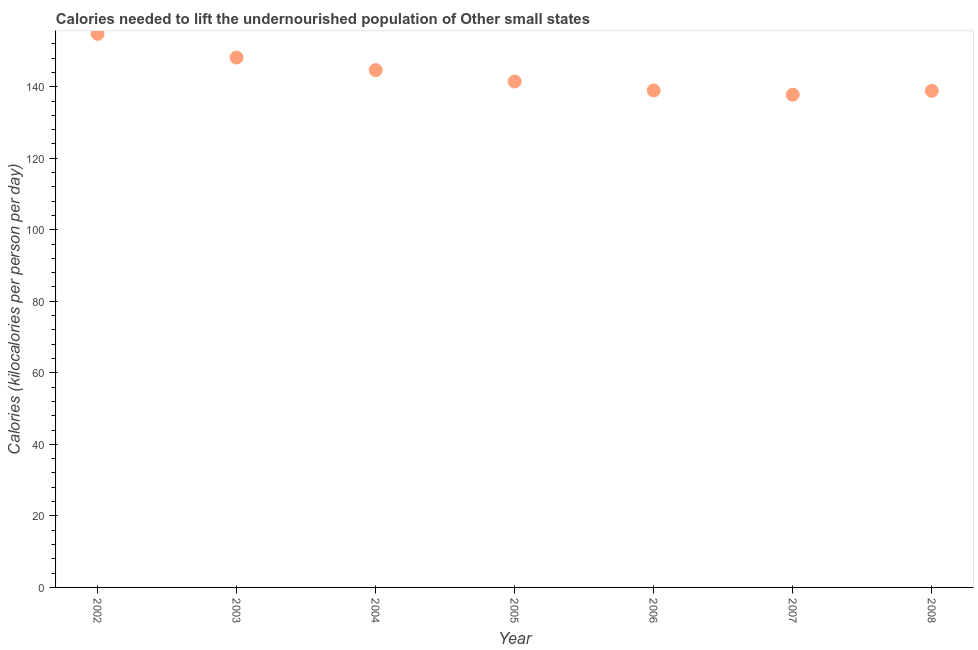What is the depth of food deficit in 2002?
Offer a terse response. 154.77. Across all years, what is the maximum depth of food deficit?
Your response must be concise. 154.77. Across all years, what is the minimum depth of food deficit?
Offer a very short reply. 137.76. What is the sum of the depth of food deficit?
Provide a succinct answer. 1004.58. What is the difference between the depth of food deficit in 2002 and 2008?
Your answer should be compact. 15.92. What is the average depth of food deficit per year?
Ensure brevity in your answer.  143.51. What is the median depth of food deficit?
Provide a short and direct response. 141.45. In how many years, is the depth of food deficit greater than 100 kilocalories?
Keep it short and to the point. 7. Do a majority of the years between 2006 and 2003 (inclusive) have depth of food deficit greater than 112 kilocalories?
Ensure brevity in your answer.  Yes. What is the ratio of the depth of food deficit in 2003 to that in 2004?
Make the answer very short. 1.02. What is the difference between the highest and the second highest depth of food deficit?
Give a very brief answer. 6.62. Is the sum of the depth of food deficit in 2006 and 2007 greater than the maximum depth of food deficit across all years?
Give a very brief answer. Yes. What is the difference between the highest and the lowest depth of food deficit?
Give a very brief answer. 17.01. In how many years, is the depth of food deficit greater than the average depth of food deficit taken over all years?
Offer a very short reply. 3. How many years are there in the graph?
Provide a succinct answer. 7. Are the values on the major ticks of Y-axis written in scientific E-notation?
Offer a terse response. No. Does the graph contain grids?
Provide a short and direct response. No. What is the title of the graph?
Make the answer very short. Calories needed to lift the undernourished population of Other small states. What is the label or title of the X-axis?
Make the answer very short. Year. What is the label or title of the Y-axis?
Your answer should be very brief. Calories (kilocalories per person per day). What is the Calories (kilocalories per person per day) in 2002?
Make the answer very short. 154.77. What is the Calories (kilocalories per person per day) in 2003?
Offer a very short reply. 148.15. What is the Calories (kilocalories per person per day) in 2004?
Your response must be concise. 144.65. What is the Calories (kilocalories per person per day) in 2005?
Make the answer very short. 141.45. What is the Calories (kilocalories per person per day) in 2006?
Your answer should be compact. 138.96. What is the Calories (kilocalories per person per day) in 2007?
Provide a succinct answer. 137.76. What is the Calories (kilocalories per person per day) in 2008?
Your response must be concise. 138.85. What is the difference between the Calories (kilocalories per person per day) in 2002 and 2003?
Offer a very short reply. 6.62. What is the difference between the Calories (kilocalories per person per day) in 2002 and 2004?
Keep it short and to the point. 10.13. What is the difference between the Calories (kilocalories per person per day) in 2002 and 2005?
Make the answer very short. 13.32. What is the difference between the Calories (kilocalories per person per day) in 2002 and 2006?
Your response must be concise. 15.82. What is the difference between the Calories (kilocalories per person per day) in 2002 and 2007?
Keep it short and to the point. 17.01. What is the difference between the Calories (kilocalories per person per day) in 2002 and 2008?
Ensure brevity in your answer.  15.92. What is the difference between the Calories (kilocalories per person per day) in 2003 and 2004?
Offer a terse response. 3.51. What is the difference between the Calories (kilocalories per person per day) in 2003 and 2005?
Provide a short and direct response. 6.71. What is the difference between the Calories (kilocalories per person per day) in 2003 and 2006?
Give a very brief answer. 9.2. What is the difference between the Calories (kilocalories per person per day) in 2003 and 2007?
Offer a terse response. 10.39. What is the difference between the Calories (kilocalories per person per day) in 2003 and 2008?
Keep it short and to the point. 9.3. What is the difference between the Calories (kilocalories per person per day) in 2004 and 2005?
Ensure brevity in your answer.  3.2. What is the difference between the Calories (kilocalories per person per day) in 2004 and 2006?
Make the answer very short. 5.69. What is the difference between the Calories (kilocalories per person per day) in 2004 and 2007?
Offer a very short reply. 6.88. What is the difference between the Calories (kilocalories per person per day) in 2004 and 2008?
Offer a very short reply. 5.79. What is the difference between the Calories (kilocalories per person per day) in 2005 and 2006?
Ensure brevity in your answer.  2.49. What is the difference between the Calories (kilocalories per person per day) in 2005 and 2007?
Give a very brief answer. 3.69. What is the difference between the Calories (kilocalories per person per day) in 2005 and 2008?
Keep it short and to the point. 2.59. What is the difference between the Calories (kilocalories per person per day) in 2006 and 2007?
Your answer should be compact. 1.19. What is the difference between the Calories (kilocalories per person per day) in 2006 and 2008?
Your answer should be compact. 0.1. What is the difference between the Calories (kilocalories per person per day) in 2007 and 2008?
Ensure brevity in your answer.  -1.09. What is the ratio of the Calories (kilocalories per person per day) in 2002 to that in 2003?
Offer a terse response. 1.04. What is the ratio of the Calories (kilocalories per person per day) in 2002 to that in 2004?
Your response must be concise. 1.07. What is the ratio of the Calories (kilocalories per person per day) in 2002 to that in 2005?
Offer a terse response. 1.09. What is the ratio of the Calories (kilocalories per person per day) in 2002 to that in 2006?
Provide a succinct answer. 1.11. What is the ratio of the Calories (kilocalories per person per day) in 2002 to that in 2007?
Your answer should be very brief. 1.12. What is the ratio of the Calories (kilocalories per person per day) in 2002 to that in 2008?
Make the answer very short. 1.11. What is the ratio of the Calories (kilocalories per person per day) in 2003 to that in 2005?
Your response must be concise. 1.05. What is the ratio of the Calories (kilocalories per person per day) in 2003 to that in 2006?
Make the answer very short. 1.07. What is the ratio of the Calories (kilocalories per person per day) in 2003 to that in 2007?
Provide a succinct answer. 1.07. What is the ratio of the Calories (kilocalories per person per day) in 2003 to that in 2008?
Make the answer very short. 1.07. What is the ratio of the Calories (kilocalories per person per day) in 2004 to that in 2006?
Your answer should be compact. 1.04. What is the ratio of the Calories (kilocalories per person per day) in 2004 to that in 2008?
Offer a very short reply. 1.04. What is the ratio of the Calories (kilocalories per person per day) in 2005 to that in 2006?
Your answer should be compact. 1.02. What is the ratio of the Calories (kilocalories per person per day) in 2005 to that in 2008?
Make the answer very short. 1.02. What is the ratio of the Calories (kilocalories per person per day) in 2006 to that in 2007?
Give a very brief answer. 1.01. What is the ratio of the Calories (kilocalories per person per day) in 2006 to that in 2008?
Make the answer very short. 1. 